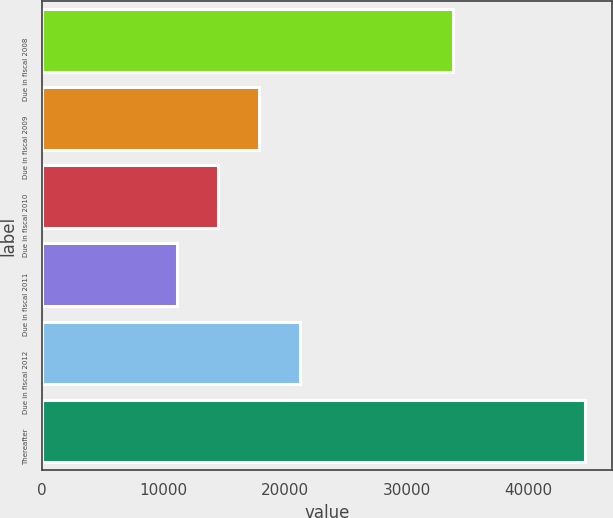<chart> <loc_0><loc_0><loc_500><loc_500><bar_chart><fcel>Due in fiscal 2008<fcel>Due in fiscal 2009<fcel>Due in fiscal 2010<fcel>Due in fiscal 2011<fcel>Due in fiscal 2012<fcel>Thereafter<nl><fcel>33758<fcel>17830.2<fcel>14476.6<fcel>11123<fcel>21183.8<fcel>44659<nl></chart> 